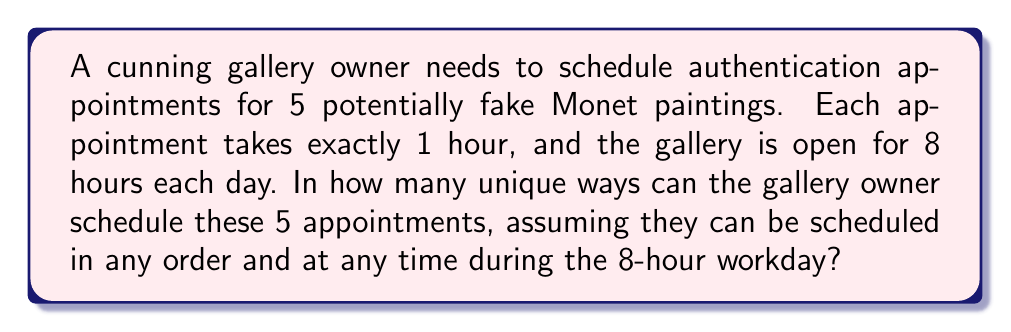Provide a solution to this math problem. Let's approach this step-by-step:

1) First, we need to recognize that this is a combination problem. We're selecting 5 hours out of 8 available hours, and the order of selection doesn't matter (as we're only interested in which hours are chosen, not the order of the appointments).

2) This scenario can be represented by the combination formula:

   $$C(n,r) = \frac{n!}{r!(n-r)!}$$

   Where $n$ is the total number of options (in this case, 8 hours), and $r$ is the number of selections (5 appointments).

3) Plugging in our values:

   $$C(8,5) = \frac{8!}{5!(8-5)!} = \frac{8!}{5!3!}$$

4) Let's calculate this:
   
   $$\frac{8 \cdot 7 \cdot 6 \cdot 5!}{5! \cdot 3 \cdot 2 \cdot 1}$$

5) The 5! cancels out in the numerator and denominator:

   $$\frac{8 \cdot 7 \cdot 6}{3 \cdot 2 \cdot 1} = \frac{336}{6} = 56$$

Therefore, there are 56 unique ways to schedule the 5 authentication appointments within the 8-hour workday.
Answer: 56 